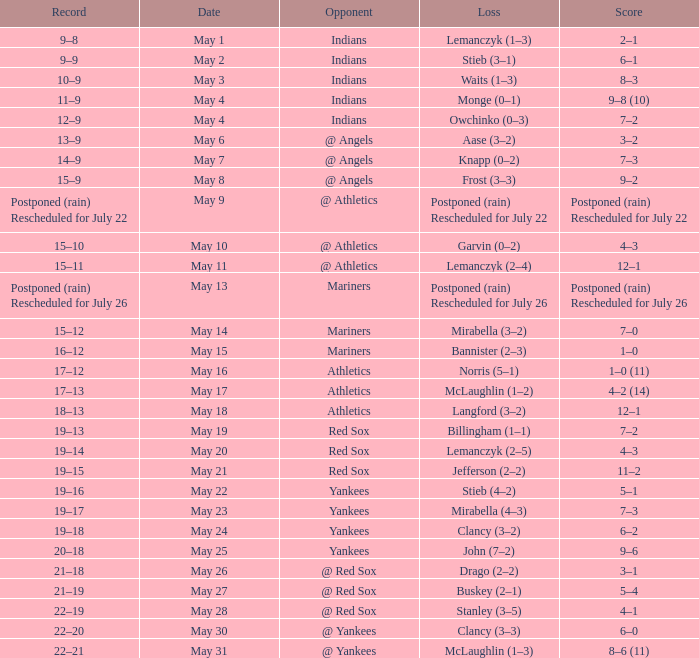Write the full table. {'header': ['Record', 'Date', 'Opponent', 'Loss', 'Score'], 'rows': [['9–8', 'May 1', 'Indians', 'Lemanczyk (1–3)', '2–1'], ['9–9', 'May 2', 'Indians', 'Stieb (3–1)', '6–1'], ['10–9', 'May 3', 'Indians', 'Waits (1–3)', '8–3'], ['11–9', 'May 4', 'Indians', 'Monge (0–1)', '9–8 (10)'], ['12–9', 'May 4', 'Indians', 'Owchinko (0–3)', '7–2'], ['13–9', 'May 6', '@ Angels', 'Aase (3–2)', '3–2'], ['14–9', 'May 7', '@ Angels', 'Knapp (0–2)', '7–3'], ['15–9', 'May 8', '@ Angels', 'Frost (3–3)', '9–2'], ['Postponed (rain) Rescheduled for July 22', 'May 9', '@ Athletics', 'Postponed (rain) Rescheduled for July 22', 'Postponed (rain) Rescheduled for July 22'], ['15–10', 'May 10', '@ Athletics', 'Garvin (0–2)', '4–3'], ['15–11', 'May 11', '@ Athletics', 'Lemanczyk (2–4)', '12–1'], ['Postponed (rain) Rescheduled for July 26', 'May 13', 'Mariners', 'Postponed (rain) Rescheduled for July 26', 'Postponed (rain) Rescheduled for July 26'], ['15–12', 'May 14', 'Mariners', 'Mirabella (3–2)', '7–0'], ['16–12', 'May 15', 'Mariners', 'Bannister (2–3)', '1–0'], ['17–12', 'May 16', 'Athletics', 'Norris (5–1)', '1–0 (11)'], ['17–13', 'May 17', 'Athletics', 'McLaughlin (1–2)', '4–2 (14)'], ['18–13', 'May 18', 'Athletics', 'Langford (3–2)', '12–1'], ['19–13', 'May 19', 'Red Sox', 'Billingham (1–1)', '7–2'], ['19–14', 'May 20', 'Red Sox', 'Lemanczyk (2–5)', '4–3'], ['19–15', 'May 21', 'Red Sox', 'Jefferson (2–2)', '11–2'], ['19–16', 'May 22', 'Yankees', 'Stieb (4–2)', '5–1'], ['19–17', 'May 23', 'Yankees', 'Mirabella (4–3)', '7–3'], ['19–18', 'May 24', 'Yankees', 'Clancy (3–2)', '6–2'], ['20–18', 'May 25', 'Yankees', 'John (7–2)', '9–6'], ['21–18', 'May 26', '@ Red Sox', 'Drago (2–2)', '3–1'], ['21–19', 'May 27', '@ Red Sox', 'Buskey (2–1)', '5–4'], ['22–19', 'May 28', '@ Red Sox', 'Stanley (3–5)', '4–1'], ['22–20', 'May 30', '@ Yankees', 'Clancy (3–3)', '6–0'], ['22–21', 'May 31', '@ Yankees', 'McLaughlin (1–3)', '8–6 (11)']]} Name the loss on may 22 Stieb (4–2). 